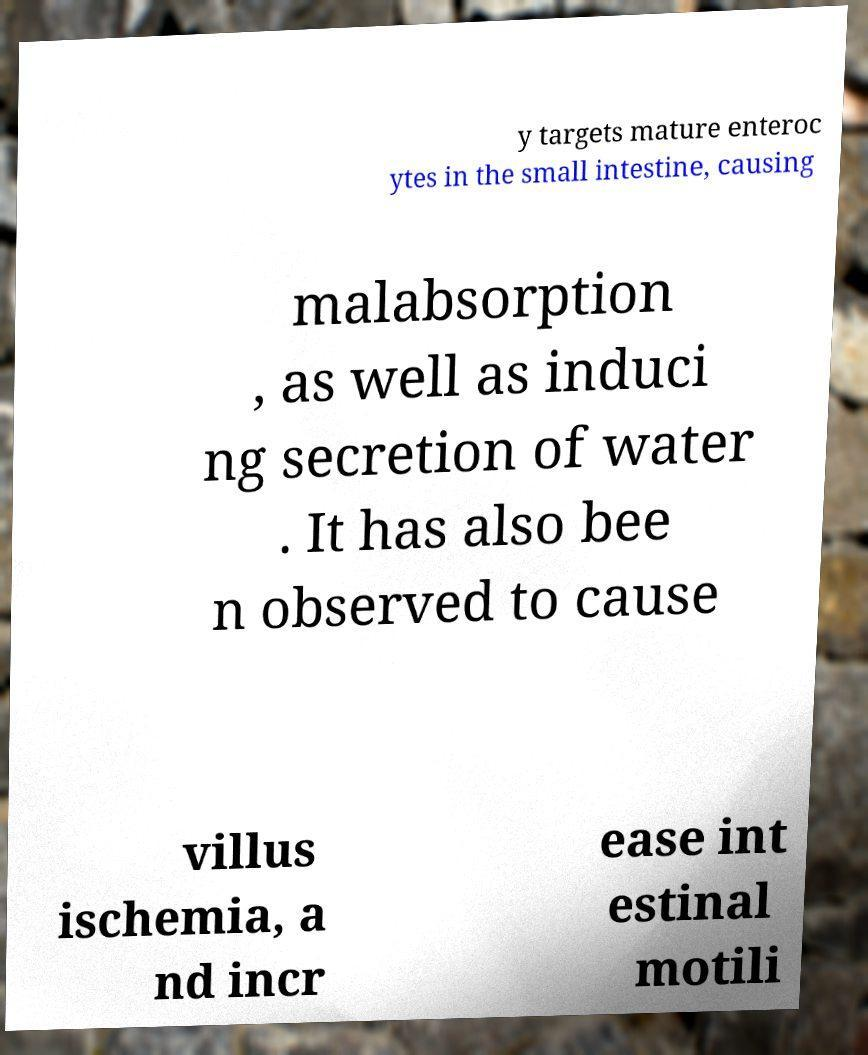Could you extract and type out the text from this image? y targets mature enteroc ytes in the small intestine, causing malabsorption , as well as induci ng secretion of water . It has also bee n observed to cause villus ischemia, a nd incr ease int estinal motili 